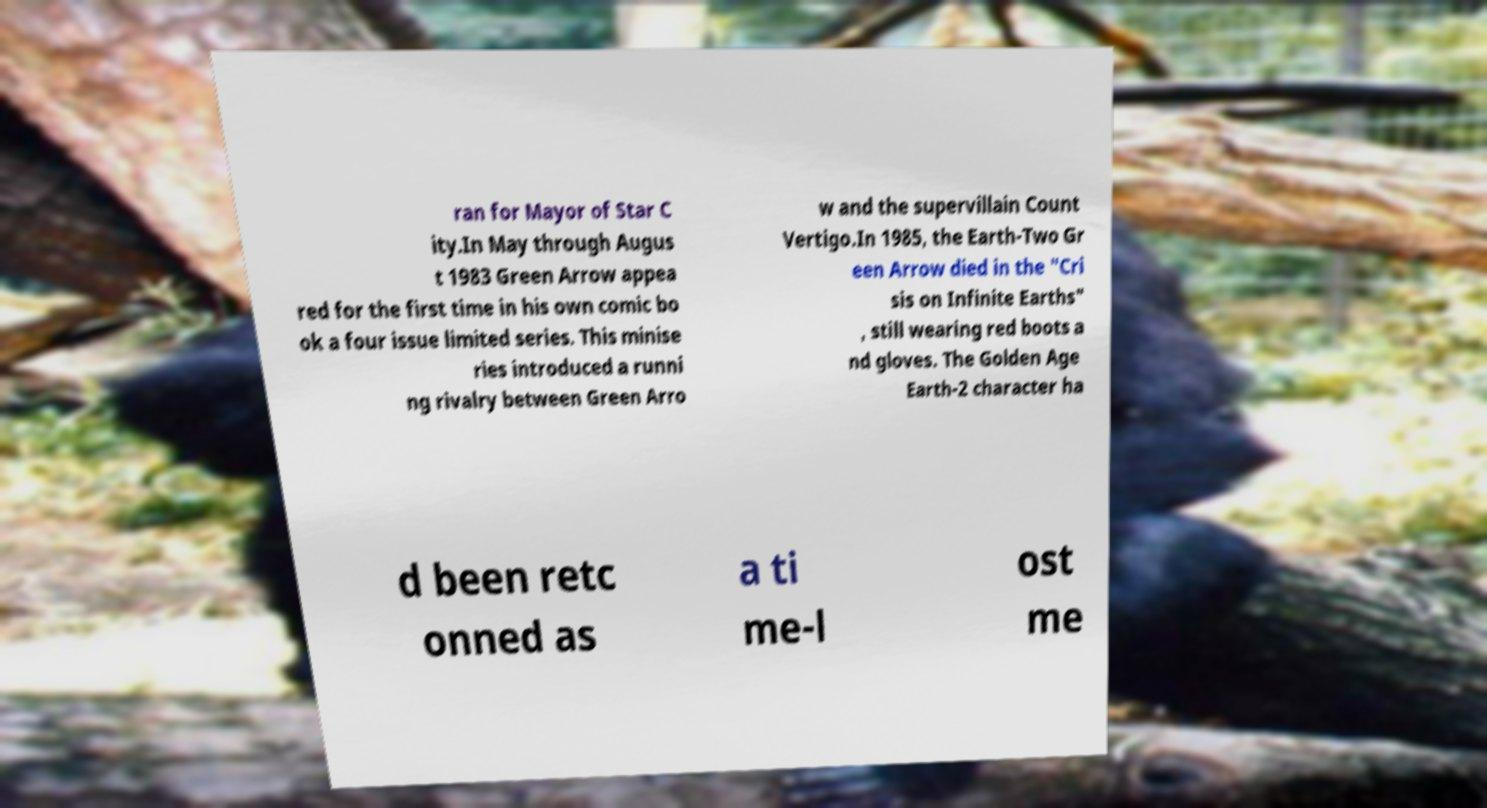Can you read and provide the text displayed in the image?This photo seems to have some interesting text. Can you extract and type it out for me? ran for Mayor of Star C ity.In May through Augus t 1983 Green Arrow appea red for the first time in his own comic bo ok a four issue limited series. This minise ries introduced a runni ng rivalry between Green Arro w and the supervillain Count Vertigo.In 1985, the Earth-Two Gr een Arrow died in the "Cri sis on Infinite Earths" , still wearing red boots a nd gloves. The Golden Age Earth-2 character ha d been retc onned as a ti me-l ost me 